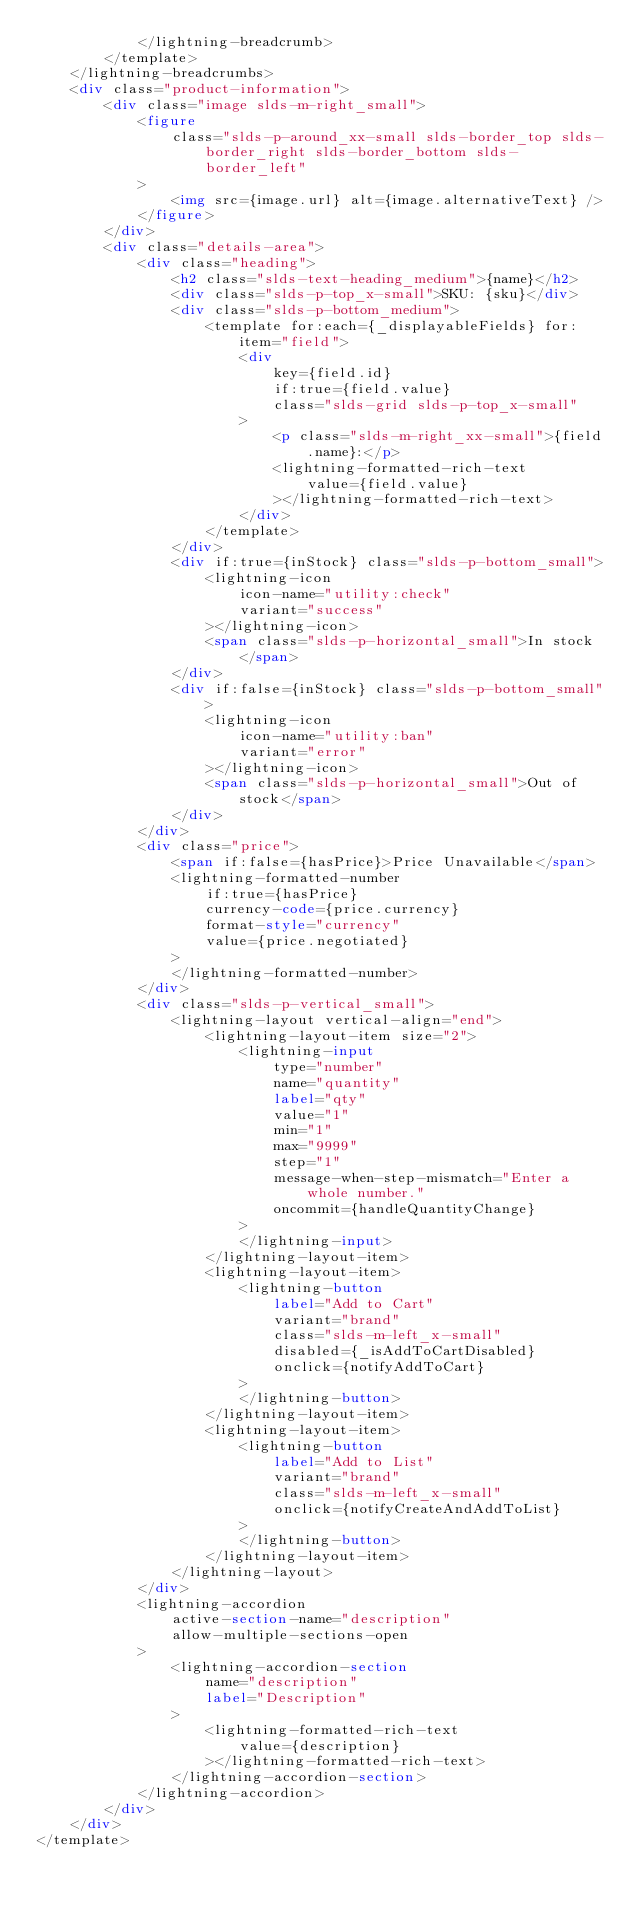<code> <loc_0><loc_0><loc_500><loc_500><_HTML_>            </lightning-breadcrumb>
        </template>
    </lightning-breadcrumbs>
    <div class="product-information">
        <div class="image slds-m-right_small">
            <figure
                class="slds-p-around_xx-small slds-border_top slds-border_right slds-border_bottom slds-border_left"
            >
                <img src={image.url} alt={image.alternativeText} />
            </figure>
        </div>
        <div class="details-area">
            <div class="heading">
                <h2 class="slds-text-heading_medium">{name}</h2>
                <div class="slds-p-top_x-small">SKU: {sku}</div>
                <div class="slds-p-bottom_medium">
                    <template for:each={_displayableFields} for:item="field">
                        <div
                            key={field.id}
                            if:true={field.value}
                            class="slds-grid slds-p-top_x-small"
                        >
                            <p class="slds-m-right_xx-small">{field.name}:</p>
                            <lightning-formatted-rich-text
                                value={field.value}
                            ></lightning-formatted-rich-text>
                        </div>
                    </template>
                </div>
                <div if:true={inStock} class="slds-p-bottom_small">
                    <lightning-icon
                        icon-name="utility:check"
                        variant="success"
                    ></lightning-icon>
                    <span class="slds-p-horizontal_small">In stock</span>
                </div>
                <div if:false={inStock} class="slds-p-bottom_small">
                    <lightning-icon
                        icon-name="utility:ban"
                        variant="error"
                    ></lightning-icon>
                    <span class="slds-p-horizontal_small">Out of stock</span>
                </div>
            </div>
            <div class="price">
                <span if:false={hasPrice}>Price Unavailable</span>
                <lightning-formatted-number
                    if:true={hasPrice}
                    currency-code={price.currency}
                    format-style="currency"
                    value={price.negotiated}
                >
                </lightning-formatted-number>
            </div>
            <div class="slds-p-vertical_small">
                <lightning-layout vertical-align="end">
                    <lightning-layout-item size="2">
                        <lightning-input
                            type="number"
                            name="quantity"
                            label="qty"
                            value="1"
                            min="1"
                            max="9999"
                            step="1"
                            message-when-step-mismatch="Enter a whole number."
                            oncommit={handleQuantityChange}
                        >
                        </lightning-input>
                    </lightning-layout-item>
                    <lightning-layout-item>
                        <lightning-button
                            label="Add to Cart"
                            variant="brand"
                            class="slds-m-left_x-small"
                            disabled={_isAddToCartDisabled}
                            onclick={notifyAddToCart}
                        >
                        </lightning-button>
                    </lightning-layout-item>
                    <lightning-layout-item>
                        <lightning-button
                            label="Add to List"
                            variant="brand"
                            class="slds-m-left_x-small"
                            onclick={notifyCreateAndAddToList}
                        >
                        </lightning-button>
                    </lightning-layout-item>
                </lightning-layout>
            </div>
            <lightning-accordion
                active-section-name="description"
                allow-multiple-sections-open
            >
                <lightning-accordion-section
                    name="description"
                    label="Description"
                >
                    <lightning-formatted-rich-text
                        value={description}
                    ></lightning-formatted-rich-text>
                </lightning-accordion-section>
            </lightning-accordion>
        </div>
    </div>
</template>
</code> 